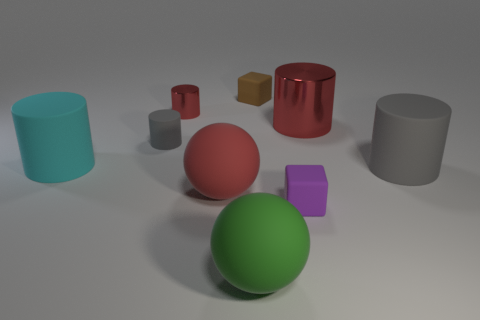Subtract all red balls. How many red cylinders are left? 2 Subtract all large rubber cylinders. How many cylinders are left? 3 Subtract 2 cylinders. How many cylinders are left? 3 Subtract all cyan cylinders. How many cylinders are left? 4 Subtract all cyan cylinders. Subtract all brown cubes. How many cylinders are left? 4 Subtract all blocks. How many objects are left? 7 Add 7 small gray cylinders. How many small gray cylinders exist? 8 Subtract 1 cyan cylinders. How many objects are left? 8 Subtract all small yellow spheres. Subtract all purple things. How many objects are left? 8 Add 5 large cyan rubber objects. How many large cyan rubber objects are left? 6 